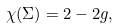Convert formula to latex. <formula><loc_0><loc_0><loc_500><loc_500>\chi ( \Sigma ) = 2 - 2 g ,</formula> 